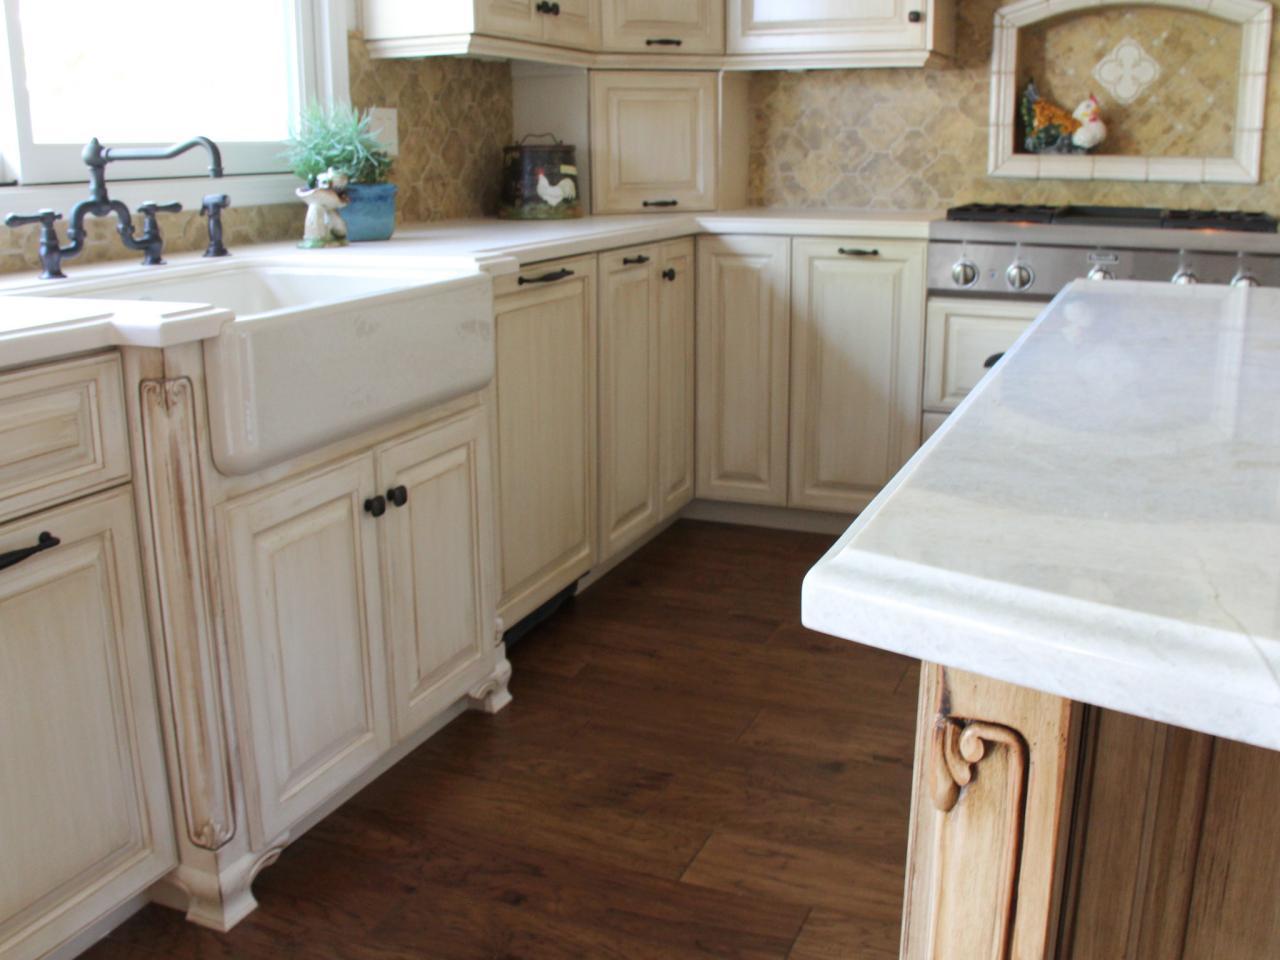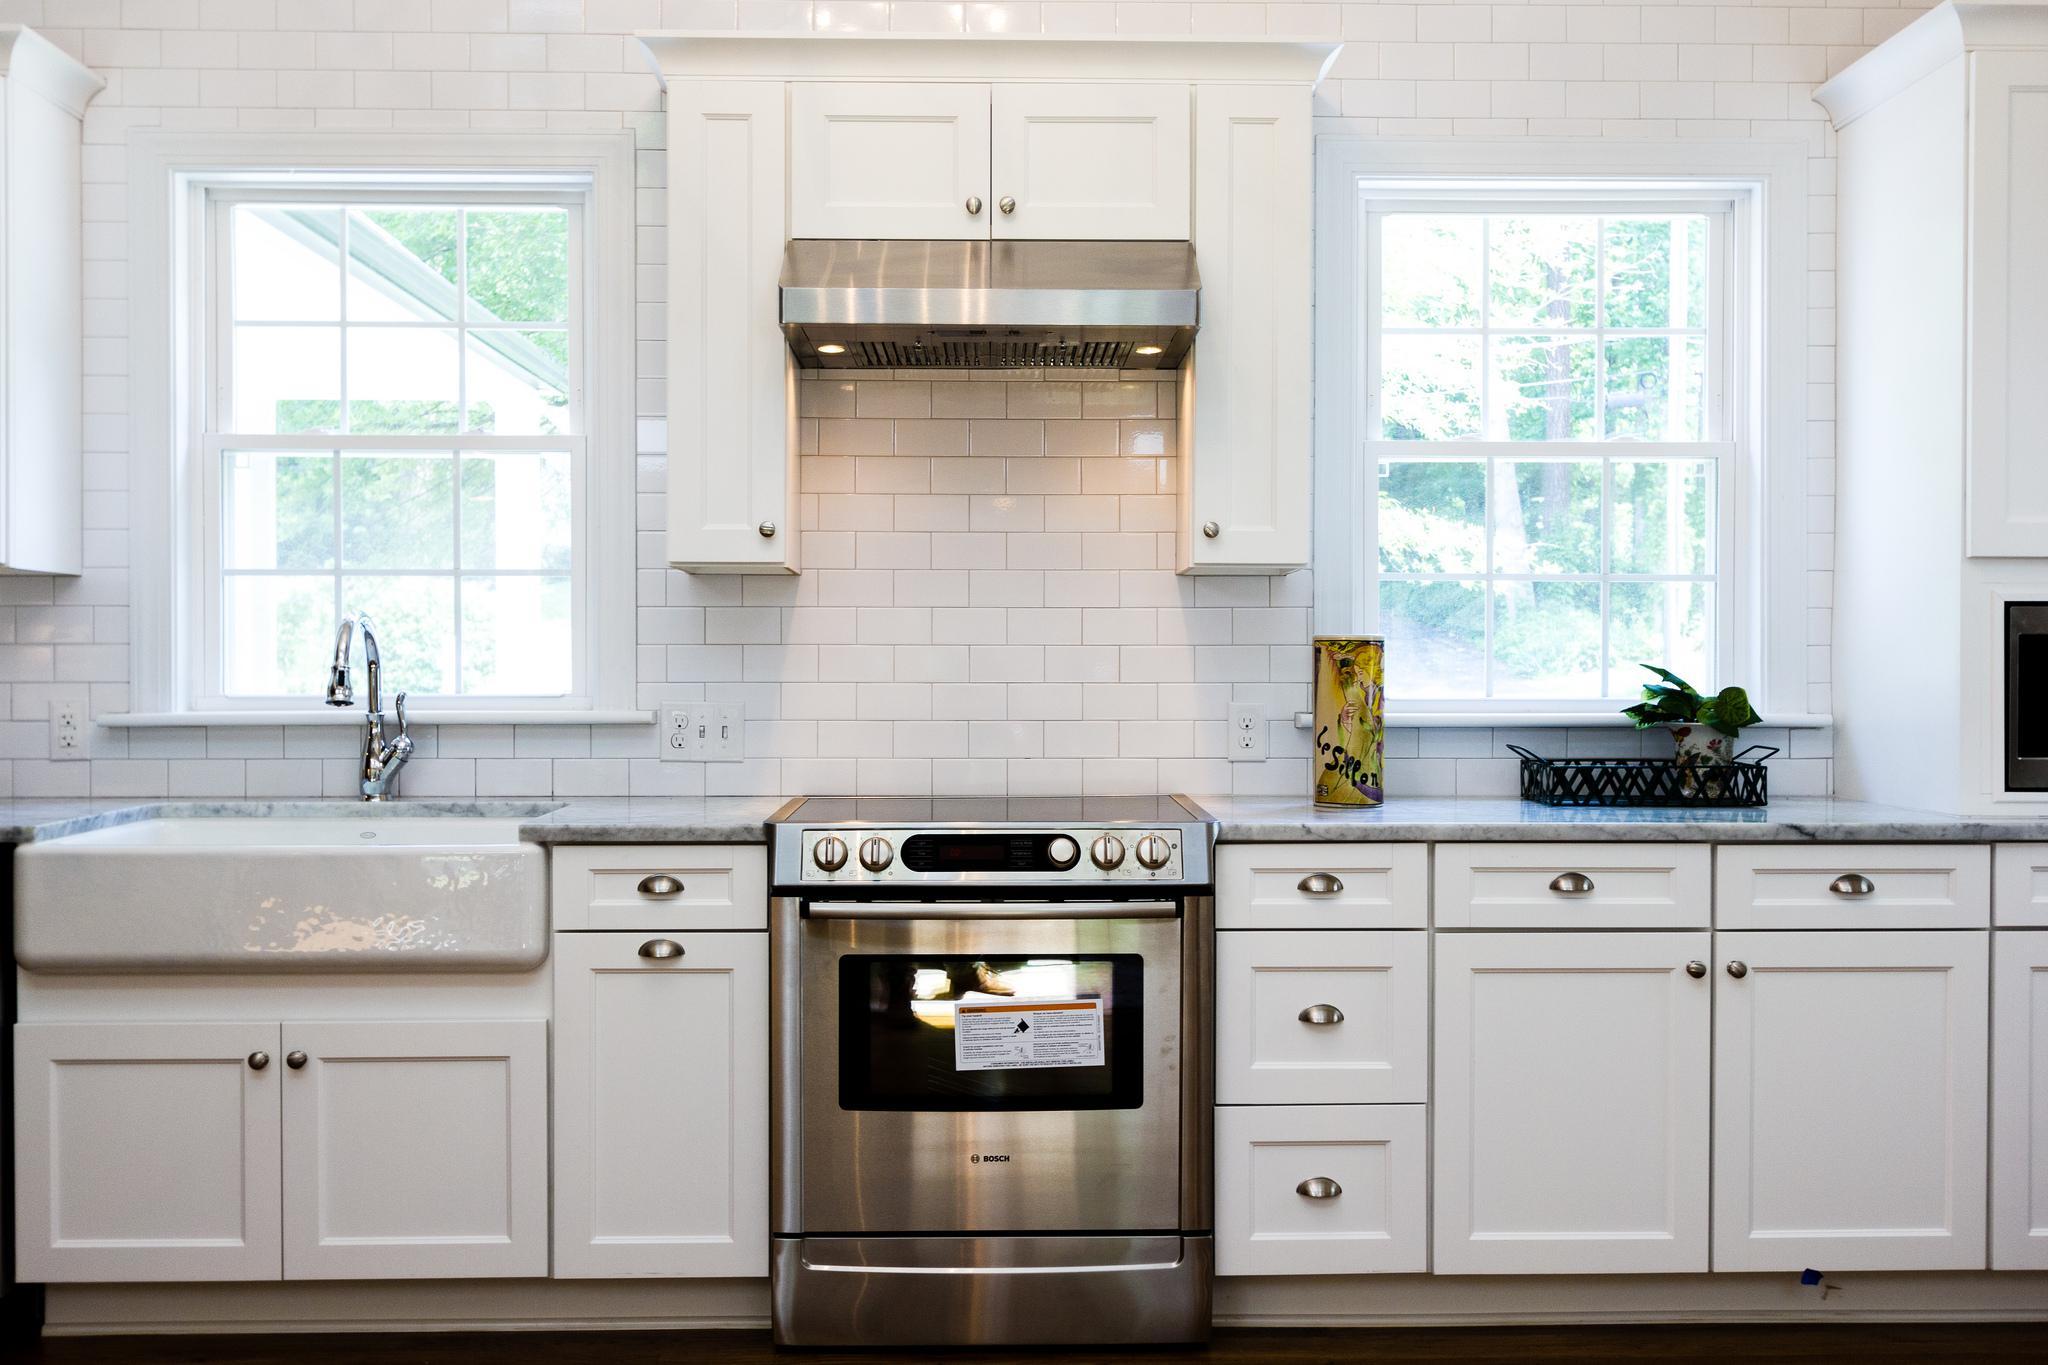The first image is the image on the left, the second image is the image on the right. Assess this claim about the two images: "In one image, a stainless steel kitchen sink with arc spout is set on a white base cabinet.". Correct or not? Answer yes or no. No. The first image is the image on the left, the second image is the image on the right. Analyze the images presented: Is the assertion "An island with a white counter sits in the middle of a kitchen." valid? Answer yes or no. Yes. 